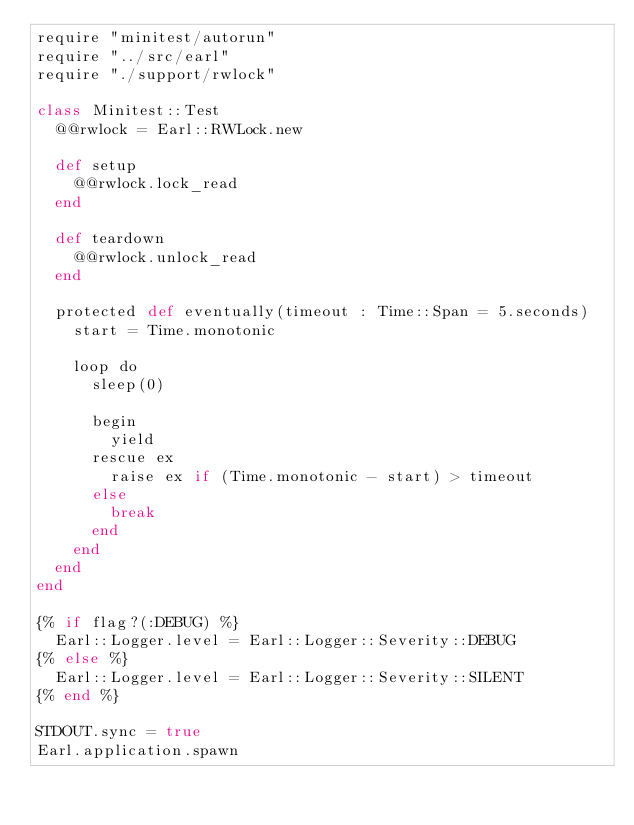<code> <loc_0><loc_0><loc_500><loc_500><_Crystal_>require "minitest/autorun"
require "../src/earl"
require "./support/rwlock"

class Minitest::Test
  @@rwlock = Earl::RWLock.new

  def setup
    @@rwlock.lock_read
  end

  def teardown
    @@rwlock.unlock_read
  end

  protected def eventually(timeout : Time::Span = 5.seconds)
    start = Time.monotonic

    loop do
      sleep(0)

      begin
        yield
      rescue ex
        raise ex if (Time.monotonic - start) > timeout
      else
        break
      end
    end
  end
end

{% if flag?(:DEBUG) %}
  Earl::Logger.level = Earl::Logger::Severity::DEBUG
{% else %}
  Earl::Logger.level = Earl::Logger::Severity::SILENT
{% end %}

STDOUT.sync = true
Earl.application.spawn
</code> 